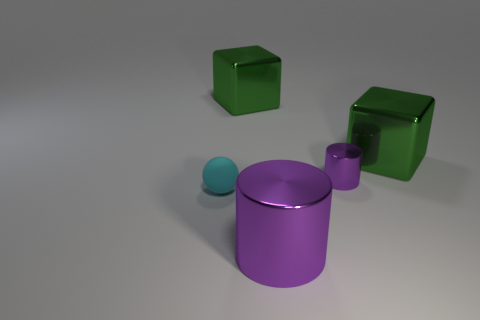Subtract all blue cylinders. Subtract all gray blocks. How many cylinders are left? 2 Add 1 big purple cylinders. How many objects exist? 6 Subtract all blocks. How many objects are left? 3 Subtract all purple cylinders. Subtract all small blue rubber blocks. How many objects are left? 3 Add 4 rubber balls. How many rubber balls are left? 5 Add 4 small purple metallic things. How many small purple metallic things exist? 5 Subtract 0 cyan cylinders. How many objects are left? 5 